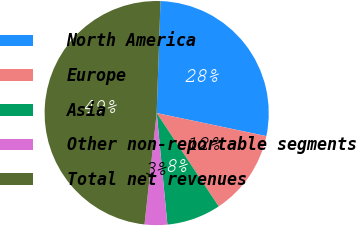Convert chart. <chart><loc_0><loc_0><loc_500><loc_500><pie_chart><fcel>North America<fcel>Europe<fcel>Asia<fcel>Other non-reportable segments<fcel>Total net revenues<nl><fcel>27.75%<fcel>12.37%<fcel>7.81%<fcel>3.26%<fcel>48.81%<nl></chart> 